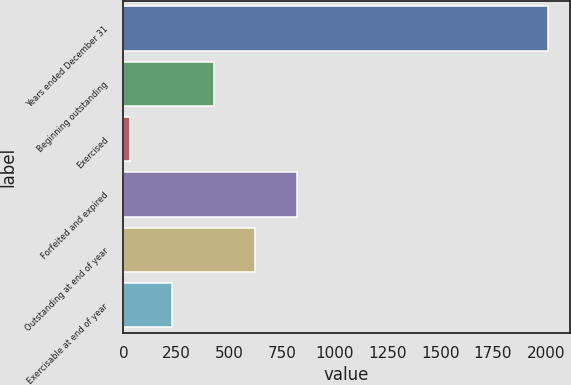Convert chart. <chart><loc_0><loc_0><loc_500><loc_500><bar_chart><fcel>Years ended December 31<fcel>Beginning outstanding<fcel>Exercised<fcel>Forfeited and expired<fcel>Outstanding at end of year<fcel>Exercisable at end of year<nl><fcel>2012<fcel>427.2<fcel>31<fcel>823.4<fcel>625.3<fcel>229.1<nl></chart> 